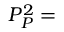Convert formula to latex. <formula><loc_0><loc_0><loc_500><loc_500>P _ { P } ^ { 2 } =</formula> 